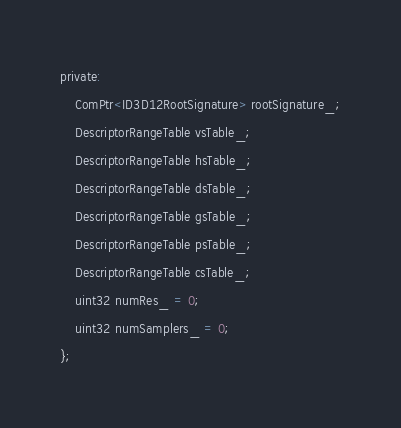Convert code to text. <code><loc_0><loc_0><loc_500><loc_500><_C_>private:
	ComPtr<ID3D12RootSignature> rootSignature_;
	DescriptorRangeTable vsTable_;
	DescriptorRangeTable hsTable_;
	DescriptorRangeTable dsTable_;
	DescriptorRangeTable gsTable_;
	DescriptorRangeTable psTable_;
	DescriptorRangeTable csTable_;
	uint32 numRes_ = 0;
	uint32 numSamplers_ = 0;
};

</code> 